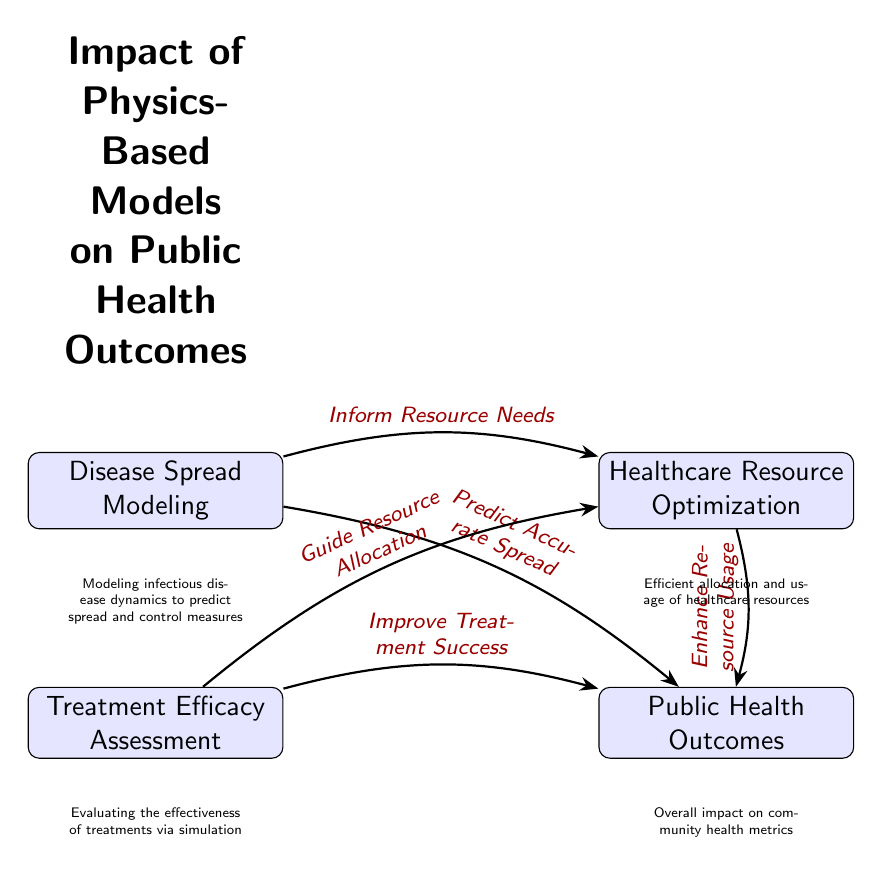What is one of the nodes in the diagram? The diagram includes several nodes; one of them is labeled "Disease Spread Modeling."
Answer: Disease Spread Modeling How many main nodes are there in the diagram? The diagram consists of three main nodes: "Disease Spread Modeling," "Treatment Efficacy Assessment," and "Healthcare Resource Optimization." Thus, there are three main nodes in total.
Answer: 3 What does "Disease Spread Modeling" predict? The edge labeled "Predict Accurate Spread" connects "Disease Spread Modeling" to "Public Health Outcomes," indicating that it predicts the accurate spread of disease.
Answer: Accurate Spread Which node contributes to "Healthcare Resource Optimization"? The node "Disease Spread Modeling" informs resource needs, which contributes to "Healthcare Resource Optimization."
Answer: Disease Spread Modeling What is the effect of "Treatment Efficacy Assessment" on public health outcomes? The edge labeled "Improve Treatment Success" directly indicates that "Treatment Efficacy Assessment" enhances treatment success, thereby positively affecting public health outcomes.
Answer: Improve Treatment Success What relationship exists between "Treatment Efficacy Assessment" and "Healthcare Resource Optimization"? According to the edge labeled "Guide Resource Allocation," "Treatment Efficacy Assessment" guides the allocation of healthcare resources that optimizes them.
Answer: Guide Resource Allocation Which node has an arrow directed towards "Public Health Outcomes"? There are multiple arrows directed towards "Public Health Outcomes," including those from "Disease Spread Modeling," "Treatment Efficacy Assessment," and "Healthcare Resource Optimization."
Answer: Disease Spread Modeling, Treatment Efficacy Assessment, Healthcare Resource Optimization How does "Healthcare Resource Optimization" affect public health outcomes? The edge labeled "Enhance Resource Usage" indicates that "Healthcare Resource Optimization" enhances the usage of healthcare resources, which in turn improves public health outcomes.
Answer: Enhance Resource Usage In what context are physics-based models applied according to the diagram? The diagram demonstrates their application in modeling disease spread, assessing treatment efficacy, and optimizing healthcare resource usage to improve overall public health outcomes.
Answer: Public Health Outcomes 